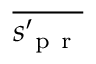<formula> <loc_0><loc_0><loc_500><loc_500>\overline { { s _ { p r } ^ { \prime } } }</formula> 